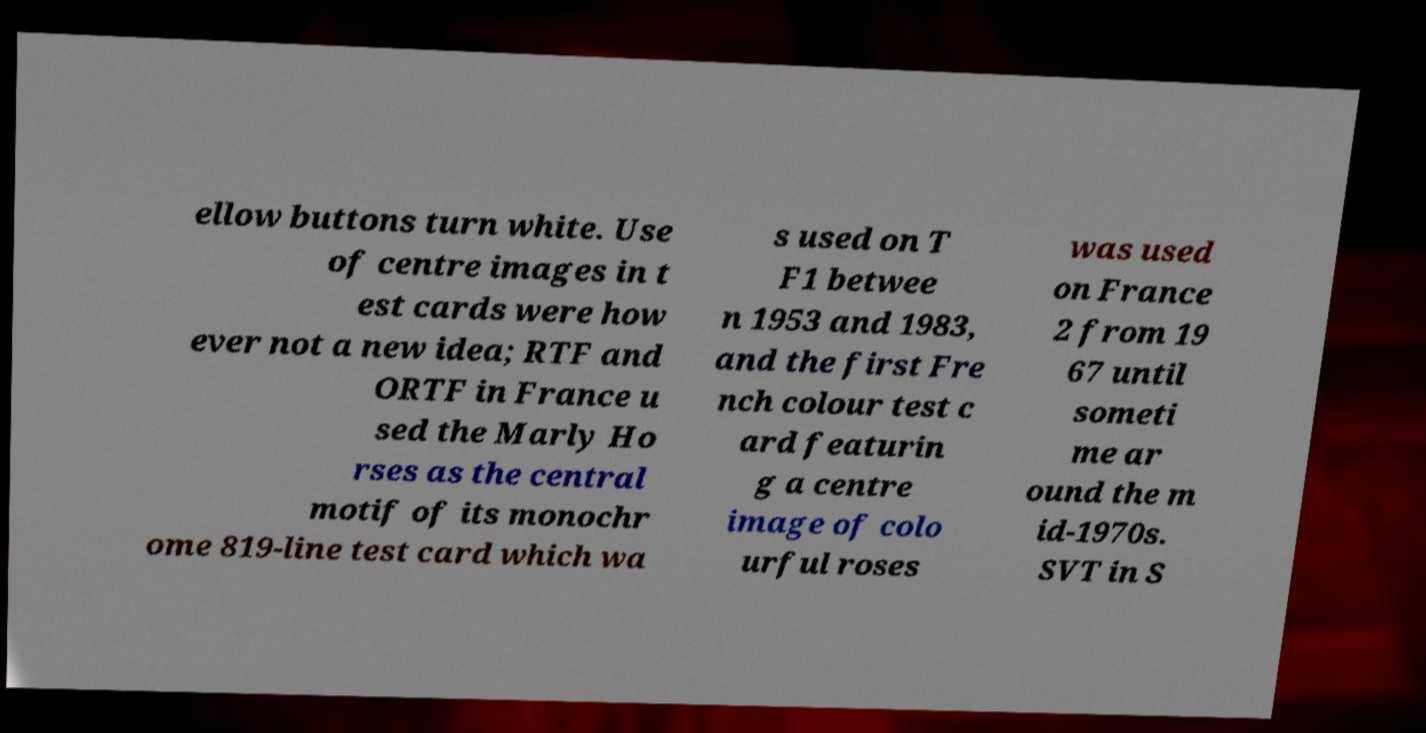Please identify and transcribe the text found in this image. ellow buttons turn white. Use of centre images in t est cards were how ever not a new idea; RTF and ORTF in France u sed the Marly Ho rses as the central motif of its monochr ome 819-line test card which wa s used on T F1 betwee n 1953 and 1983, and the first Fre nch colour test c ard featurin g a centre image of colo urful roses was used on France 2 from 19 67 until someti me ar ound the m id-1970s. SVT in S 